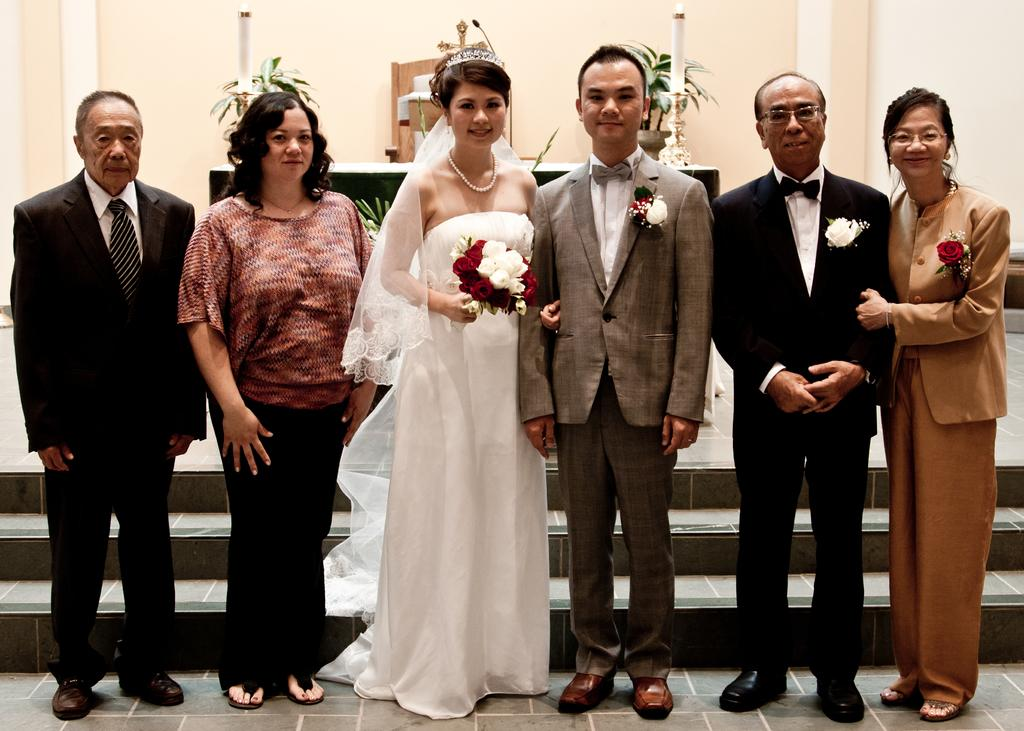What are the people in the image doing? The persons standing on the floor are likely engaged in some activity or standing together. Can you describe any objects or items being held by the people? One person is holding a flower bouquet. What can be seen in the background of the image? There are plants and a wall visible in the background. What type of flesh can be seen on the person holding the flower bouquet? There is no flesh visible on the person holding the flower bouquet in the image. Is there an office setting in the image? The image does not depict an office setting; it features persons standing on the floor with a background of plants and a wall. 